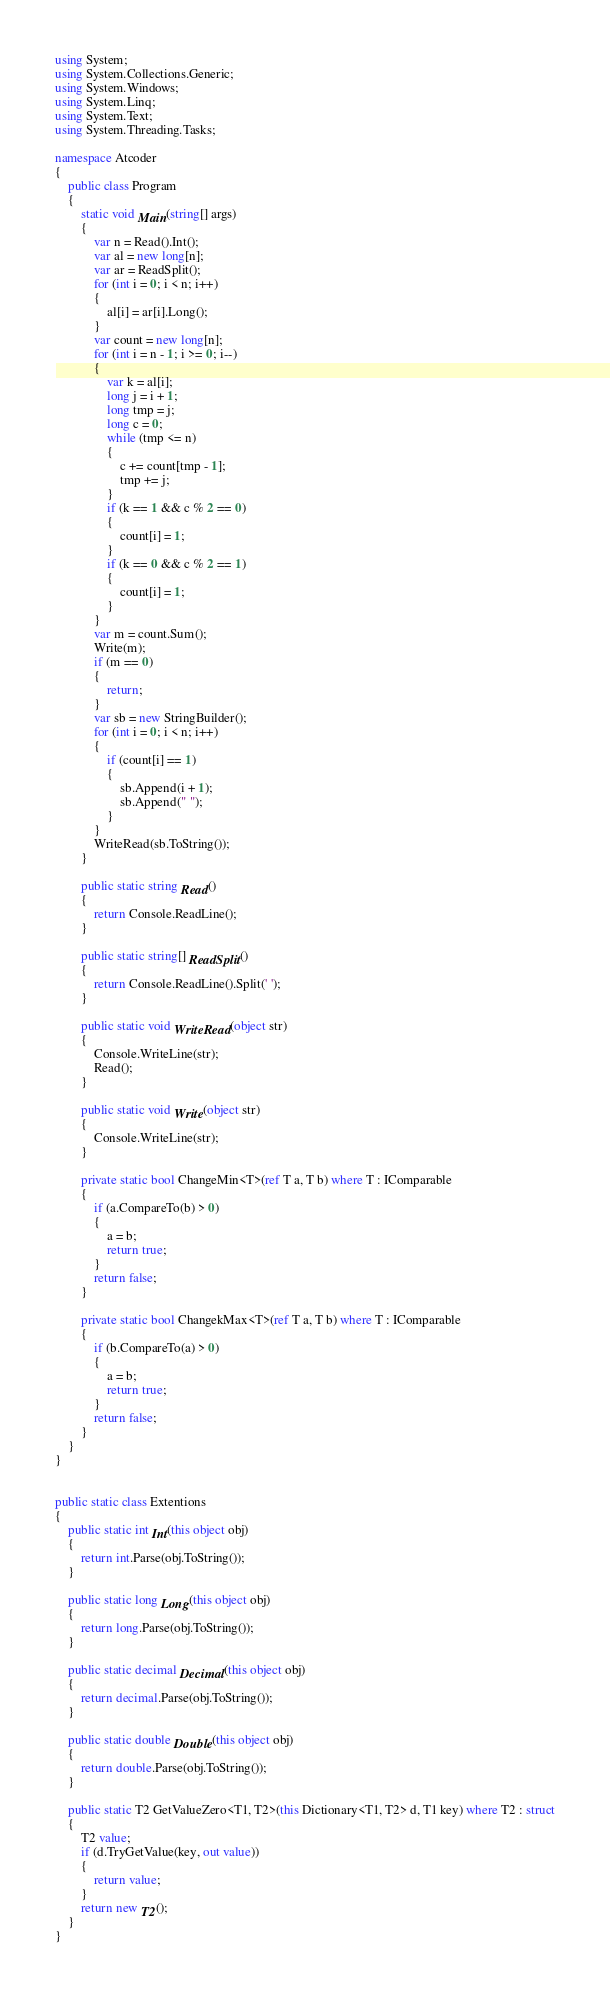<code> <loc_0><loc_0><loc_500><loc_500><_C#_>using System;
using System.Collections.Generic;
using System.Windows;
using System.Linq;
using System.Text;
using System.Threading.Tasks;

namespace Atcoder
{
    public class Program
    {
        static void Main(string[] args)
        {
            var n = Read().Int();
            var al = new long[n];
            var ar = ReadSplit();
            for (int i = 0; i < n; i++)
            {
                al[i] = ar[i].Long();
            }
            var count = new long[n];
            for (int i = n - 1; i >= 0; i--)
            {
                var k = al[i];
                long j = i + 1;
                long tmp = j;
                long c = 0;
                while (tmp <= n)
                {
                    c += count[tmp - 1];
                    tmp += j;
                }
                if (k == 1 && c % 2 == 0)
                {
                    count[i] = 1;
                }
                if (k == 0 && c % 2 == 1)
                {
                    count[i] = 1;
                }
            }
            var m = count.Sum();
            Write(m);
            if (m == 0)
            {
                return;
            }
            var sb = new StringBuilder();
            for (int i = 0; i < n; i++)
            {
                if (count[i] == 1)
                {
                    sb.Append(i + 1);
                    sb.Append(" ");
                }
            }
            WriteRead(sb.ToString());
        }
        
        public static string Read()
        {
            return Console.ReadLine();
        }

        public static string[] ReadSplit()
        {
            return Console.ReadLine().Split(' ');
        }

        public static void WriteRead(object str)
        {
            Console.WriteLine(str);
            Read();
        }

        public static void Write(object str)
        {
            Console.WriteLine(str);
        }

        private static bool ChangeMin<T>(ref T a, T b) where T : IComparable
        {
            if (a.CompareTo(b) > 0)
            {
                a = b;
                return true;
            }
            return false;
        }

        private static bool ChangekMax<T>(ref T a, T b) where T : IComparable
        {
            if (b.CompareTo(a) > 0)
            {
                a = b;
                return true;
            }
            return false;
        }
    }
}


public static class Extentions
{
    public static int Int(this object obj)
    {
        return int.Parse(obj.ToString());
    }

    public static long Long(this object obj)
    {
        return long.Parse(obj.ToString());
    }

    public static decimal Decimal(this object obj)
    {
        return decimal.Parse(obj.ToString());
    }

    public static double Double(this object obj)
    {
        return double.Parse(obj.ToString());
    }

    public static T2 GetValueZero<T1, T2>(this Dictionary<T1, T2> d, T1 key) where T2 : struct
    {
        T2 value;
        if (d.TryGetValue(key, out value))
        {
            return value;
        }
        return new T2();
    }
}

</code> 